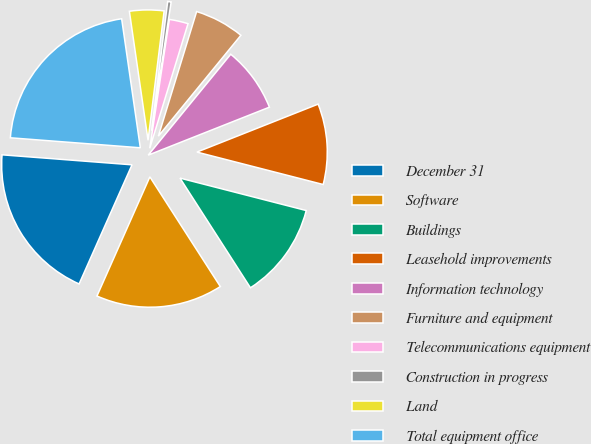Convert chart. <chart><loc_0><loc_0><loc_500><loc_500><pie_chart><fcel>December 31<fcel>Software<fcel>Buildings<fcel>Leasehold improvements<fcel>Information technology<fcel>Furniture and equipment<fcel>Telecommunications equipment<fcel>Construction in progress<fcel>Land<fcel>Total equipment office<nl><fcel>19.57%<fcel>15.74%<fcel>11.91%<fcel>10.0%<fcel>8.09%<fcel>6.17%<fcel>2.34%<fcel>0.43%<fcel>4.26%<fcel>21.49%<nl></chart> 